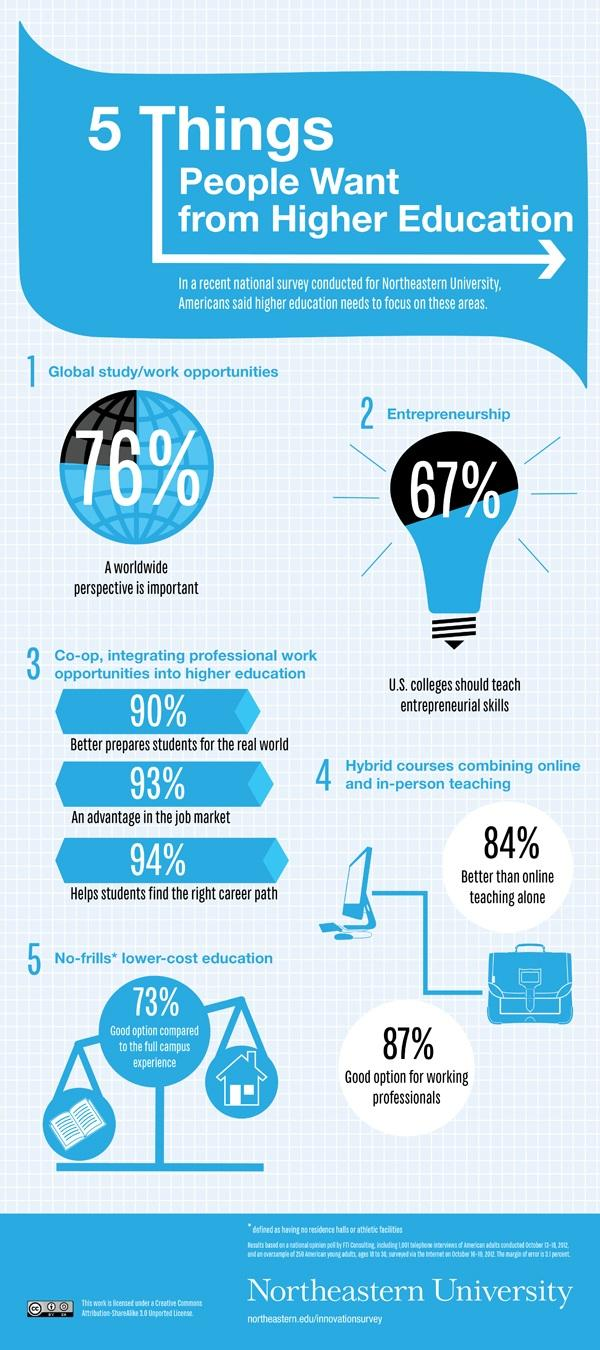Specify some key components in this picture. According to a survey, 67% of respondents believe that entrepreneurship skills should be taught in colleges. 